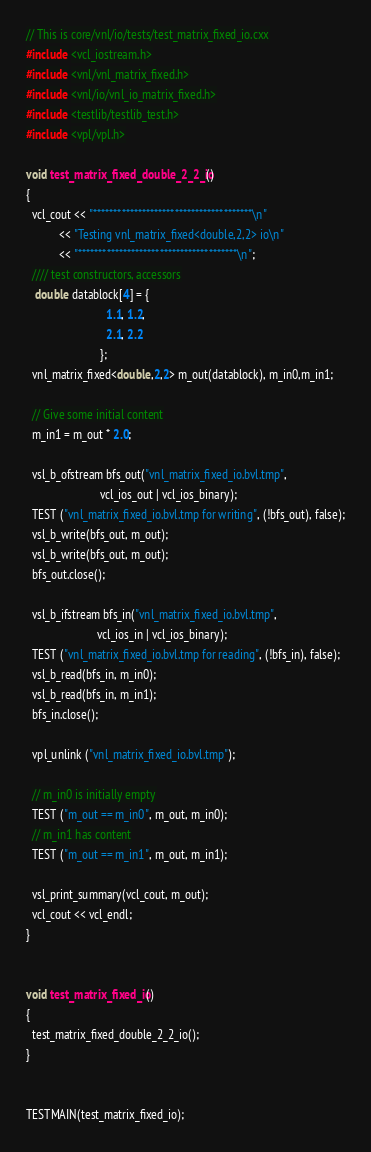<code> <loc_0><loc_0><loc_500><loc_500><_C++_>// This is core/vnl/io/tests/test_matrix_fixed_io.cxx
#include <vcl_iostream.h>
#include <vnl/vnl_matrix_fixed.h>
#include <vnl/io/vnl_io_matrix_fixed.h>
#include <testlib/testlib_test.h>
#include <vpl/vpl.h>

void test_matrix_fixed_double_2_2_io()
{
  vcl_cout << "***************************************\n"
           << "Testing vnl_matrix_fixed<double,2,2> io\n"
           << "***************************************\n";
  //// test constructors, accessors
   double datablock[4] = {
                           1.1, 1.2,
                           2.1, 2.2
                         };
  vnl_matrix_fixed<double,2,2> m_out(datablock), m_in0,m_in1;

  // Give some initial content
  m_in1 = m_out * 2.0;

  vsl_b_ofstream bfs_out("vnl_matrix_fixed_io.bvl.tmp",
                         vcl_ios_out | vcl_ios_binary);
  TEST ("vnl_matrix_fixed_io.bvl.tmp for writing", (!bfs_out), false);
  vsl_b_write(bfs_out, m_out);
  vsl_b_write(bfs_out, m_out);
  bfs_out.close();

  vsl_b_ifstream bfs_in("vnl_matrix_fixed_io.bvl.tmp",
                        vcl_ios_in | vcl_ios_binary);
  TEST ("vnl_matrix_fixed_io.bvl.tmp for reading", (!bfs_in), false);
  vsl_b_read(bfs_in, m_in0);
  vsl_b_read(bfs_in, m_in1);
  bfs_in.close();

  vpl_unlink ("vnl_matrix_fixed_io.bvl.tmp");

  // m_in0 is initially empty
  TEST ("m_out == m_in0", m_out, m_in0);
  // m_in1 has content
  TEST ("m_out == m_in1", m_out, m_in1);

  vsl_print_summary(vcl_cout, m_out);
  vcl_cout << vcl_endl;
}


void test_matrix_fixed_io()
{
  test_matrix_fixed_double_2_2_io();
}


TESTMAIN(test_matrix_fixed_io);
</code> 